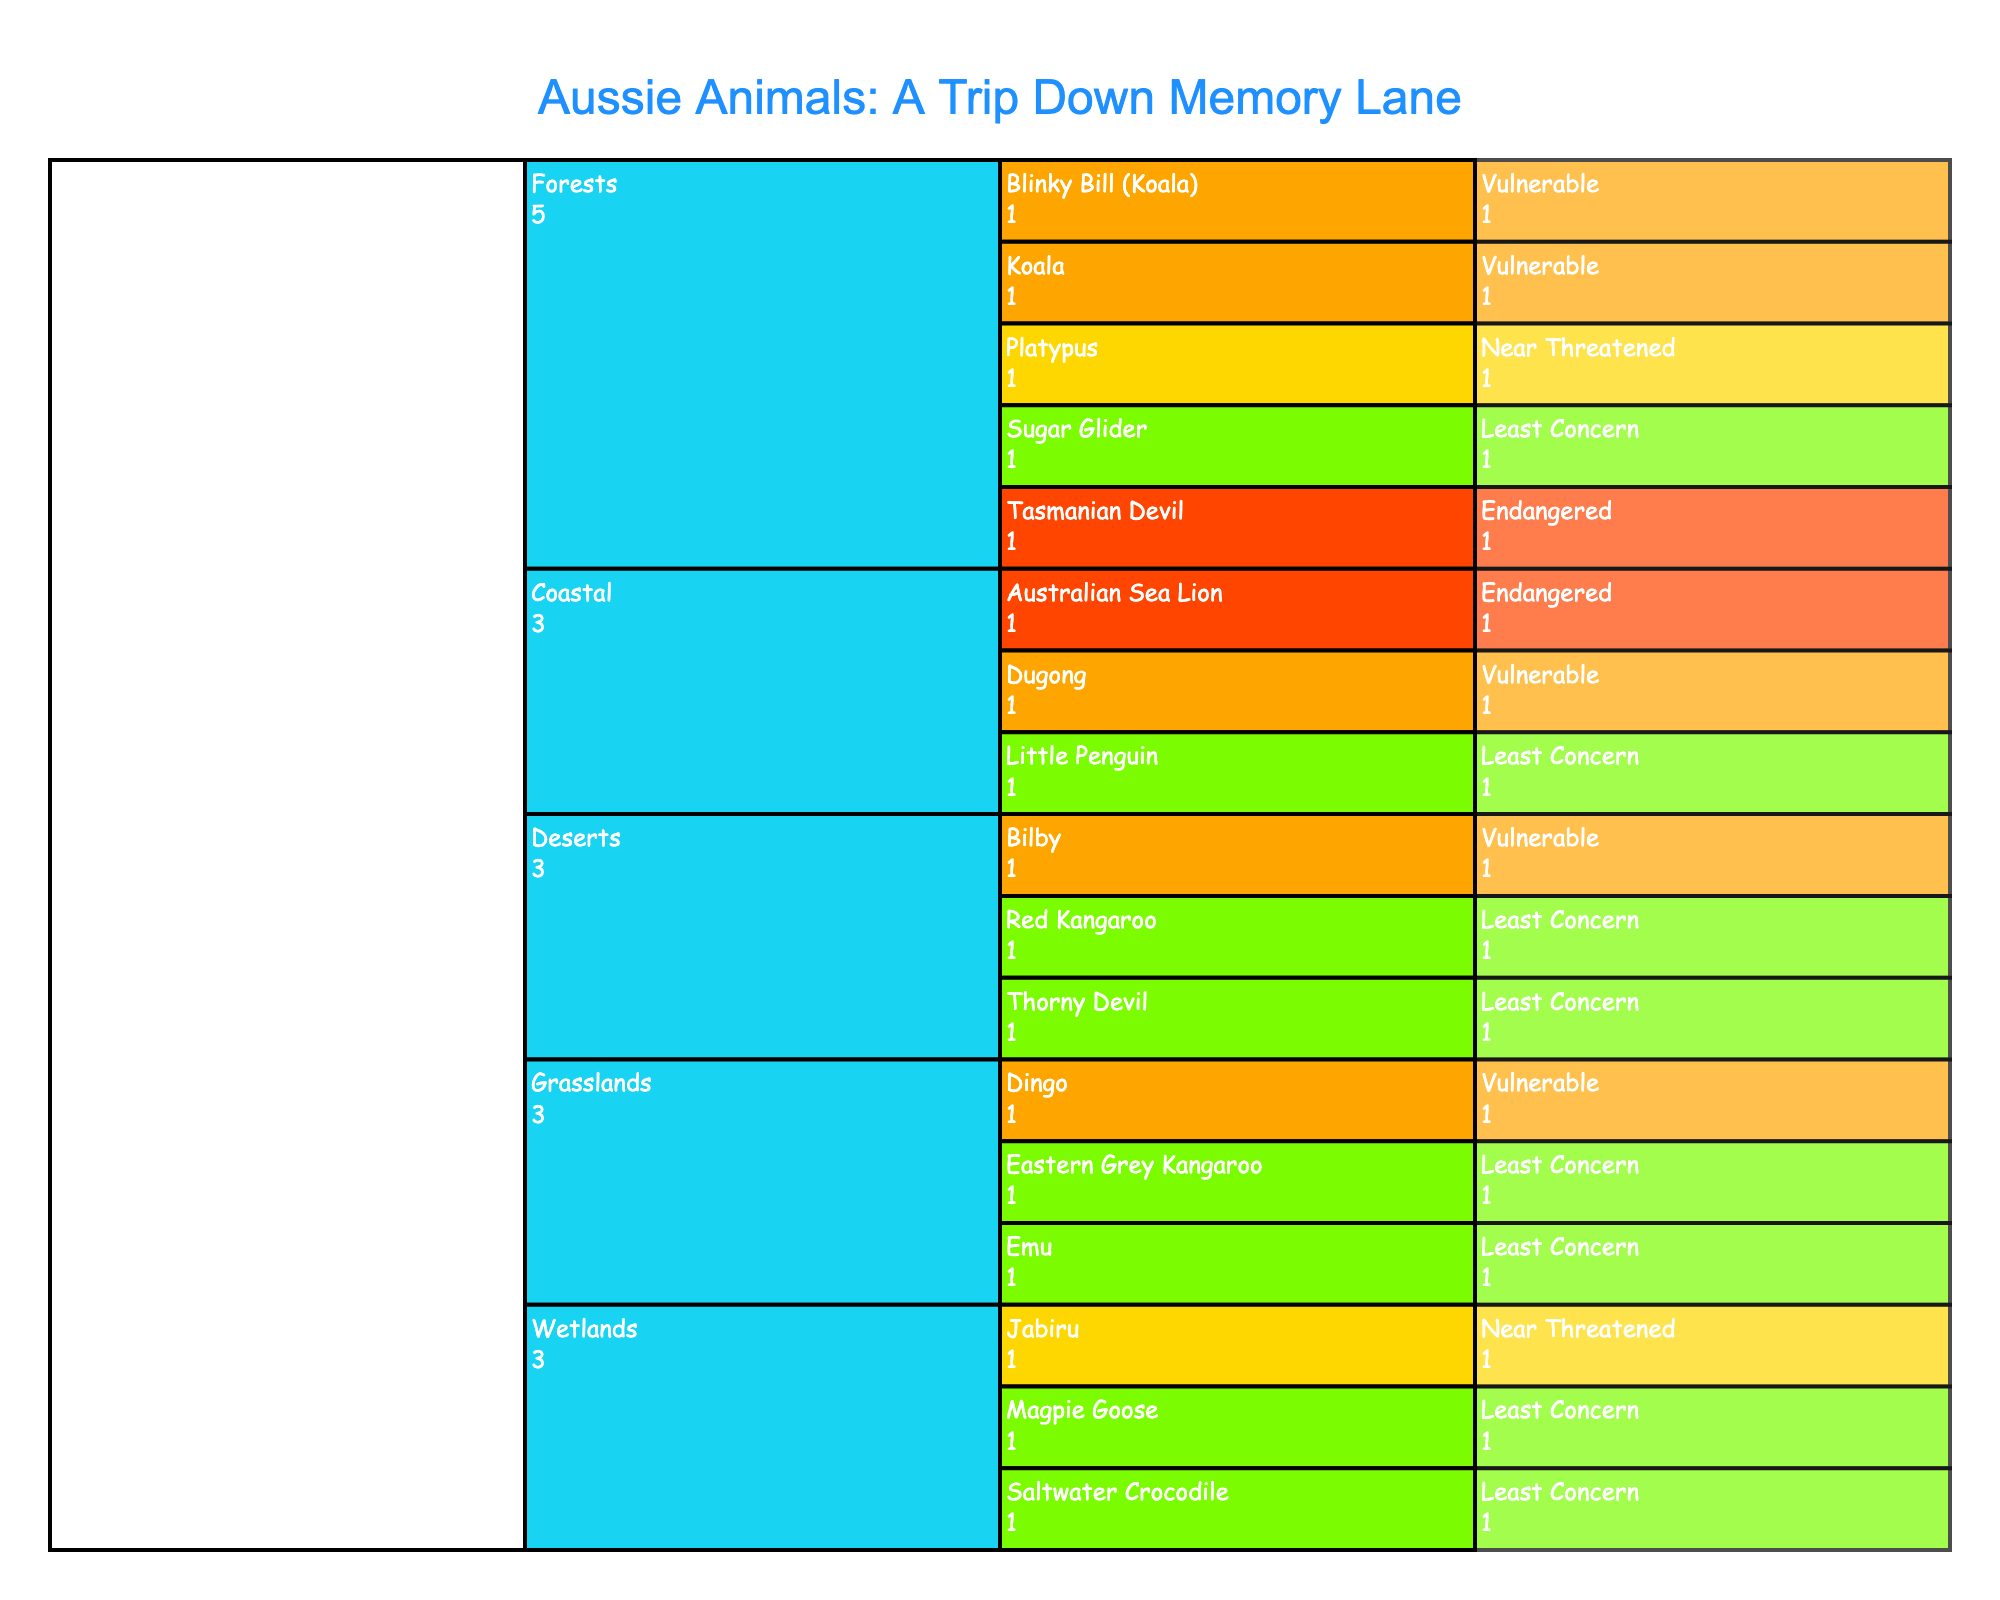Which habitat contains the most species? Look at the icicle chart and count the top-level branches representing different habitats. Forests have the most sub-branches, each representing a species.
Answer: Forests What is the conservation status of Blinky Bill? Find Blinky Bill under the "Forests" habitat in the icicle chart. The color and label will indicate the conservation status is "Vulnerable".
Answer: Vulnerable How many endangered animal species are depicted in the figure? Identify the branches colored in the shade representing "Endangered". Count them. There are two animals: Tasmanian Devil and Australian Sea Lion.
Answer: 2 Which habitats contain species classified as "Near Threatened"? Locate the sections with the color representing "Near Threatened" and note their habitats. These are Platypus (Forests) and Jabiru (Wetlands).
Answer: Forests and Wetlands If a species from Grasslands is removed, how many species will remain in that habitat? There are three species in Grasslands: Eastern Grey Kangaroo, Emu, and Dingo. Removing one leaves two.
Answer: 2 Among the Vulnerable species, which habitats can they be found in? Identify the sections with Vulnerable species and note their habitats. These are Koala (Forests), Blinky Bill (Forests), Dingo (Grasslands), Bilby (Deserts), and Dugong (Coastal).
Answer: Forests, Grasslands, Deserts, Coastal Are there more Least Concern species or Vulnerable species? Count the number of branches colored for "Least Concern" (6 species) and for "Vulnerable" (5 species). There are more Least Concern species.
Answer: Least Concern How many animal species are found in Wetlands? Look under the Wetlands section and count the species: Saltwater Crocodile, Magpie Goose, and Jabiru.
Answer: 3 Which habitat has no species with the status "Endangered"? Check each habitat and observe if there is any section colored for "Endangered". Grasslands, Deserts, and Wetlands do not have Endangered species.
Answer: Grasslands, Deserts, Wetlands 